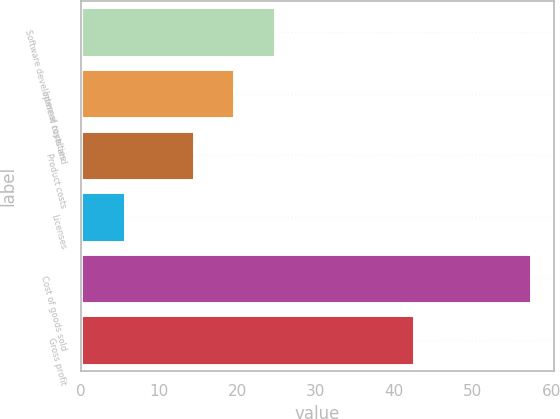Convert chart. <chart><loc_0><loc_0><loc_500><loc_500><bar_chart><fcel>Software development costs and<fcel>Internal royalties<fcel>Product costs<fcel>Licenses<fcel>Cost of goods sold<fcel>Gross profit<nl><fcel>24.78<fcel>19.59<fcel>14.4<fcel>5.6<fcel>57.5<fcel>42.5<nl></chart> 